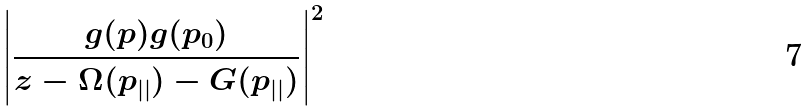<formula> <loc_0><loc_0><loc_500><loc_500>\left | \frac { g ( p ) g ( p _ { 0 } ) } { z - \Omega ( p _ { | | } ) - G ( p _ { | | } ) } \right | ^ { 2 }</formula> 